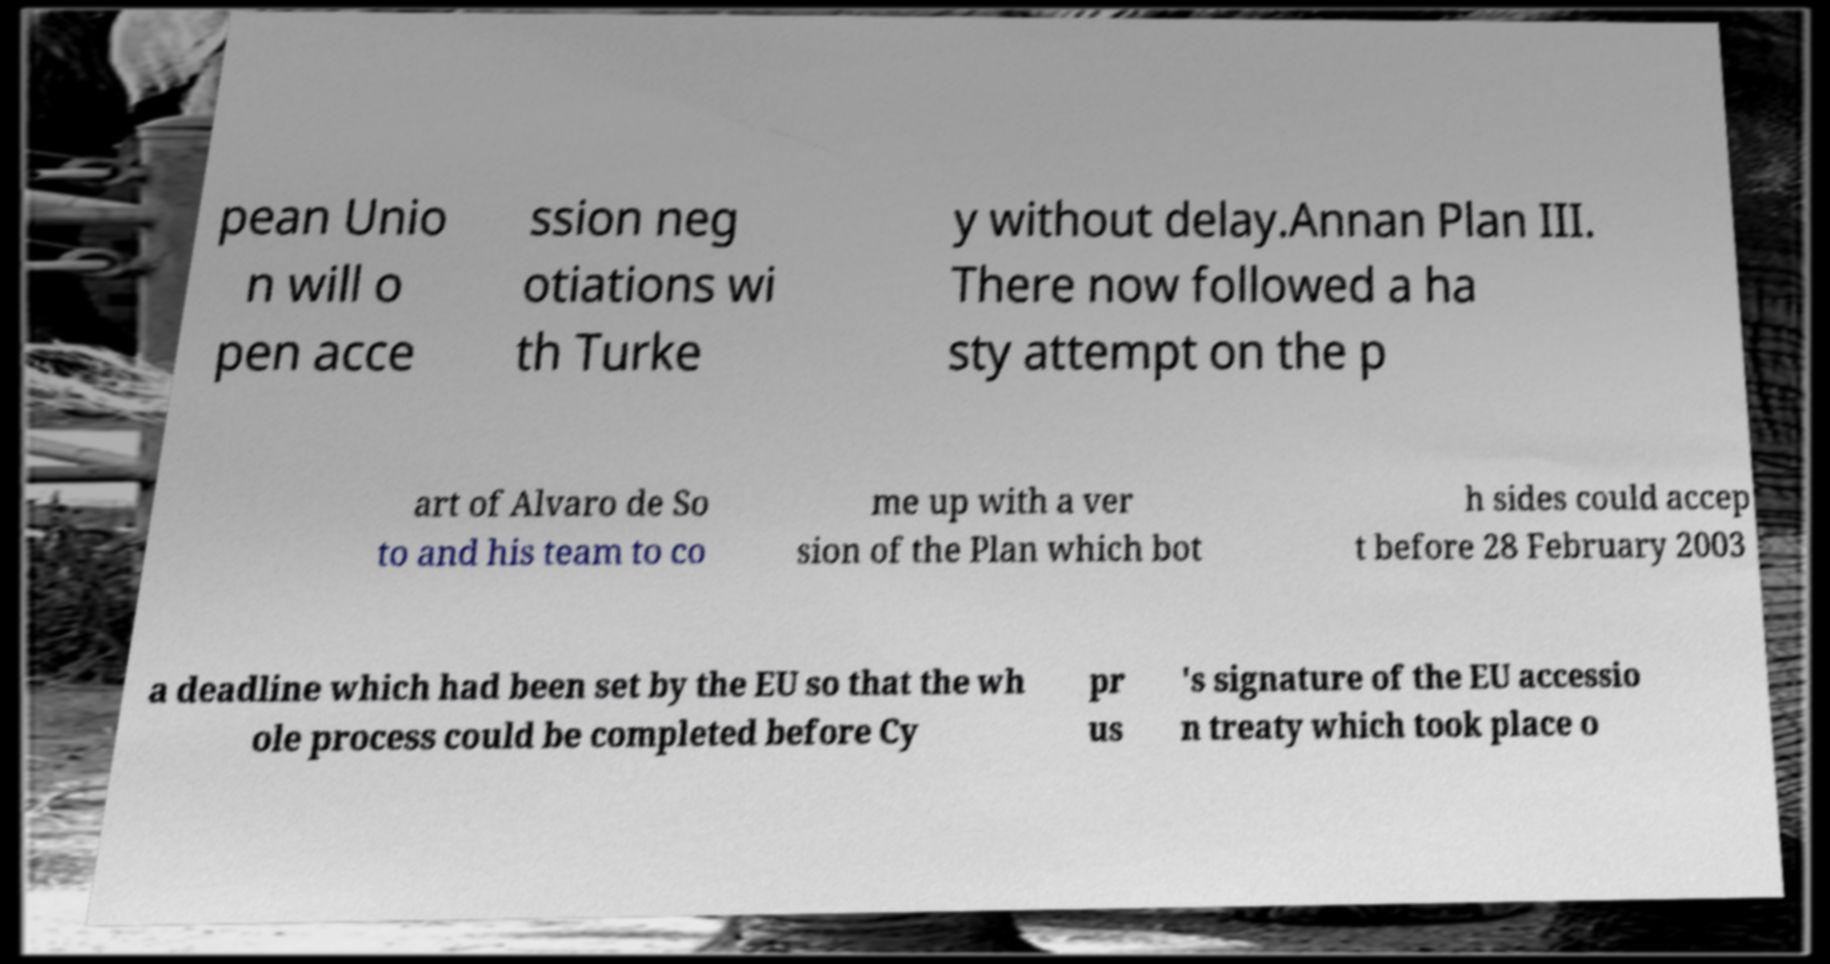There's text embedded in this image that I need extracted. Can you transcribe it verbatim? pean Unio n will o pen acce ssion neg otiations wi th Turke y without delay.Annan Plan III. There now followed a ha sty attempt on the p art of Alvaro de So to and his team to co me up with a ver sion of the Plan which bot h sides could accep t before 28 February 2003 a deadline which had been set by the EU so that the wh ole process could be completed before Cy pr us 's signature of the EU accessio n treaty which took place o 